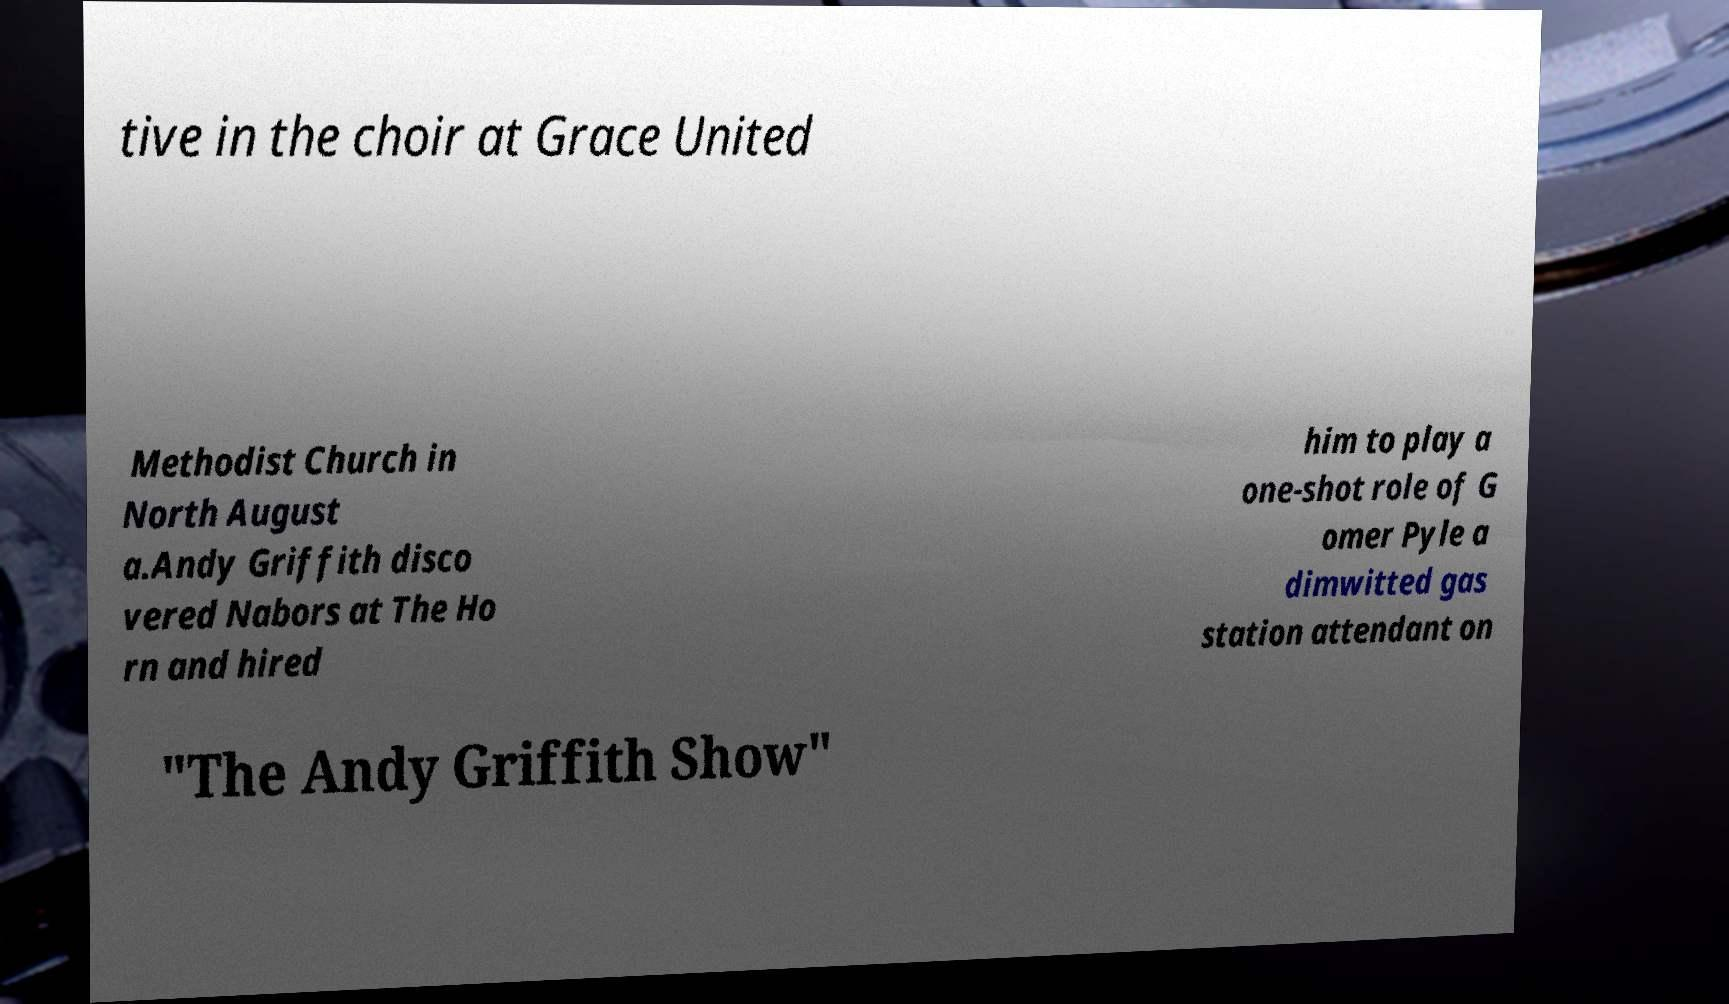There's text embedded in this image that I need extracted. Can you transcribe it verbatim? tive in the choir at Grace United Methodist Church in North August a.Andy Griffith disco vered Nabors at The Ho rn and hired him to play a one-shot role of G omer Pyle a dimwitted gas station attendant on "The Andy Griffith Show" 